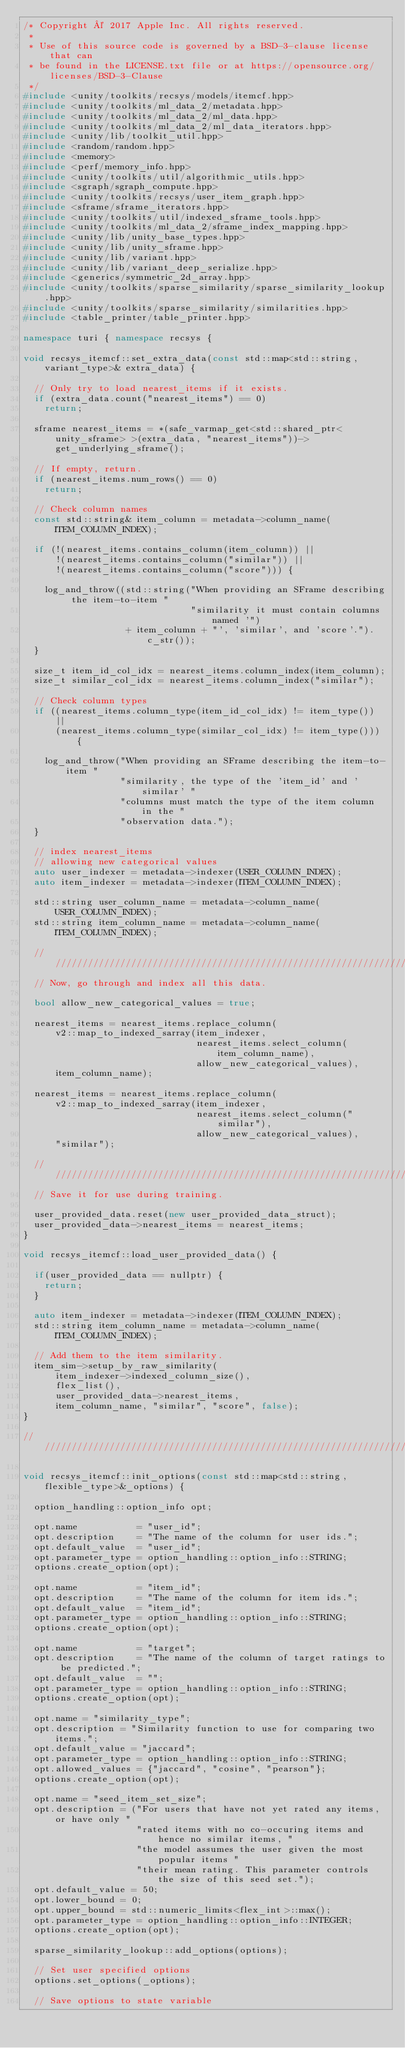<code> <loc_0><loc_0><loc_500><loc_500><_C++_>/* Copyright © 2017 Apple Inc. All rights reserved.
 *
 * Use of this source code is governed by a BSD-3-clause license that can
 * be found in the LICENSE.txt file or at https://opensource.org/licenses/BSD-3-Clause
 */
#include <unity/toolkits/recsys/models/itemcf.hpp>
#include <unity/toolkits/ml_data_2/metadata.hpp>
#include <unity/toolkits/ml_data_2/ml_data.hpp>
#include <unity/toolkits/ml_data_2/ml_data_iterators.hpp>
#include <unity/lib/toolkit_util.hpp>
#include <random/random.hpp>
#include <memory>
#include <perf/memory_info.hpp>
#include <unity/toolkits/util/algorithmic_utils.hpp>
#include <sgraph/sgraph_compute.hpp> 
#include <unity/toolkits/recsys/user_item_graph.hpp>
#include <sframe/sframe_iterators.hpp>
#include <unity/toolkits/util/indexed_sframe_tools.hpp>
#include <unity/toolkits/ml_data_2/sframe_index_mapping.hpp>
#include <unity/lib/unity_base_types.hpp>
#include <unity/lib/unity_sframe.hpp>
#include <unity/lib/variant.hpp>
#include <unity/lib/variant_deep_serialize.hpp>
#include <generics/symmetric_2d_array.hpp>
#include <unity/toolkits/sparse_similarity/sparse_similarity_lookup.hpp>
#include <unity/toolkits/sparse_similarity/similarities.hpp>
#include <table_printer/table_printer.hpp>

namespace turi { namespace recsys {

void recsys_itemcf::set_extra_data(const std::map<std::string, variant_type>& extra_data) {
  
  // Only try to load nearest_items if it exists.
  if (extra_data.count("nearest_items") == 0)
    return;

  sframe nearest_items = *(safe_varmap_get<std::shared_ptr<unity_sframe> >(extra_data, "nearest_items"))->get_underlying_sframe();

  // If empty, return.
  if (nearest_items.num_rows() == 0)
    return;

  // Check column names 
  const std::string& item_column = metadata->column_name(ITEM_COLUMN_INDEX);

  if (!(nearest_items.contains_column(item_column)) ||
      !(nearest_items.contains_column("similar")) ||
      !(nearest_items.contains_column("score"))) {

    log_and_throw((std::string("When providing an SFrame describing the item-to-item "
                               "similarity it must contain columns named '")
                   + item_column + "', 'similar', and 'score'.").c_str());
  }

  size_t item_id_col_idx = nearest_items.column_index(item_column);
  size_t similar_col_idx = nearest_items.column_index("similar");

  // Check column types
  if ((nearest_items.column_type(item_id_col_idx) != item_type()) ||
      (nearest_items.column_type(similar_col_idx) != item_type())) {

    log_and_throw("When providing an SFrame describing the item-to-item "
                  "similarity, the type of the 'item_id' and 'similar' "
                  "columns must match the type of the item column in the "
                  "observation data.");
  }

  // index nearest_items
  // allowing new categorical values 
  auto user_indexer = metadata->indexer(USER_COLUMN_INDEX);
  auto item_indexer = metadata->indexer(ITEM_COLUMN_INDEX);

  std::string user_column_name = metadata->column_name(USER_COLUMN_INDEX);
  std::string item_column_name = metadata->column_name(ITEM_COLUMN_INDEX);

  ////////////////////////////////////////////////////////////////////////////////
  // Now, go through and index all this data.

  bool allow_new_categorical_values = true;

  nearest_items = nearest_items.replace_column(
      v2::map_to_indexed_sarray(item_indexer,
                                nearest_items.select_column(item_column_name),
                                allow_new_categorical_values),
      item_column_name);

  nearest_items = nearest_items.replace_column(
      v2::map_to_indexed_sarray(item_indexer,
                                nearest_items.select_column("similar"),
                                allow_new_categorical_values),
      "similar");

  ////////////////////////////////////////////////////////////////////////////////
  // Save it for use during training.

  user_provided_data.reset(new user_provided_data_struct);
  user_provided_data->nearest_items = nearest_items;
}

void recsys_itemcf::load_user_provided_data() {

  if(user_provided_data == nullptr) {
    return;
  }

  auto item_indexer = metadata->indexer(ITEM_COLUMN_INDEX);
  std::string item_column_name = metadata->column_name(ITEM_COLUMN_INDEX);

  // Add them to the item similarity.
  item_sim->setup_by_raw_similarity(
      item_indexer->indexed_column_size(),
      flex_list(),
      user_provided_data->nearest_items,
      item_column_name, "similar", "score", false);
}

////////////////////////////////////////////////////////////////////////////////

void recsys_itemcf::init_options(const std::map<std::string, flexible_type>&_options) {

  option_handling::option_info opt;

  opt.name           = "user_id";
  opt.description    = "The name of the column for user ids.";
  opt.default_value  = "user_id";
  opt.parameter_type = option_handling::option_info::STRING;
  options.create_option(opt); 

  opt.name           = "item_id";
  opt.description    = "The name of the column for item ids.";
  opt.default_value  = "item_id";
  opt.parameter_type = option_handling::option_info::STRING;
  options.create_option(opt); 

  opt.name           = "target";
  opt.description    = "The name of the column of target ratings to be predicted.";
  opt.default_value  = "";
  opt.parameter_type = option_handling::option_info::STRING;
  options.create_option(opt); 

  opt.name = "similarity_type";
  opt.description = "Similarity function to use for comparing two items.";
  opt.default_value = "jaccard";
  opt.parameter_type = option_handling::option_info::STRING;
  opt.allowed_values = {"jaccard", "cosine", "pearson"};
  options.create_option(opt); 

  opt.name = "seed_item_set_size";
  opt.description = ("For users that have not yet rated any items, or have only "
                     "rated items with no co-occuring items and hence no similar items, "
                     "the model assumes the user given the most popular items "
                     "their mean rating. This parameter controls the size of this seed set.");
  opt.default_value = 50;
  opt.lower_bound = 0;
  opt.upper_bound = std::numeric_limits<flex_int>::max();
  opt.parameter_type = option_handling::option_info::INTEGER;
  options.create_option(opt);
  
  sparse_similarity_lookup::add_options(options);

  // Set user specified options
  options.set_options(_options);

  // Save options to state variable</code> 